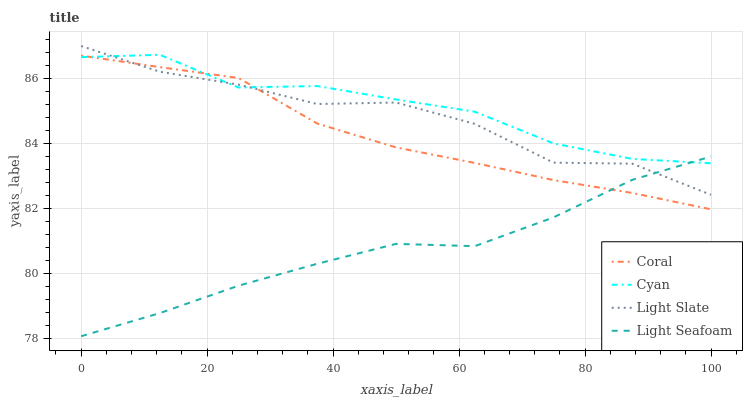Does Light Seafoam have the minimum area under the curve?
Answer yes or no. Yes. Does Cyan have the maximum area under the curve?
Answer yes or no. Yes. Does Coral have the minimum area under the curve?
Answer yes or no. No. Does Coral have the maximum area under the curve?
Answer yes or no. No. Is Coral the smoothest?
Answer yes or no. Yes. Is Light Slate the roughest?
Answer yes or no. Yes. Is Cyan the smoothest?
Answer yes or no. No. Is Cyan the roughest?
Answer yes or no. No. Does Light Seafoam have the lowest value?
Answer yes or no. Yes. Does Coral have the lowest value?
Answer yes or no. No. Does Light Slate have the highest value?
Answer yes or no. Yes. Does Cyan have the highest value?
Answer yes or no. No. Does Light Slate intersect Cyan?
Answer yes or no. Yes. Is Light Slate less than Cyan?
Answer yes or no. No. Is Light Slate greater than Cyan?
Answer yes or no. No. 